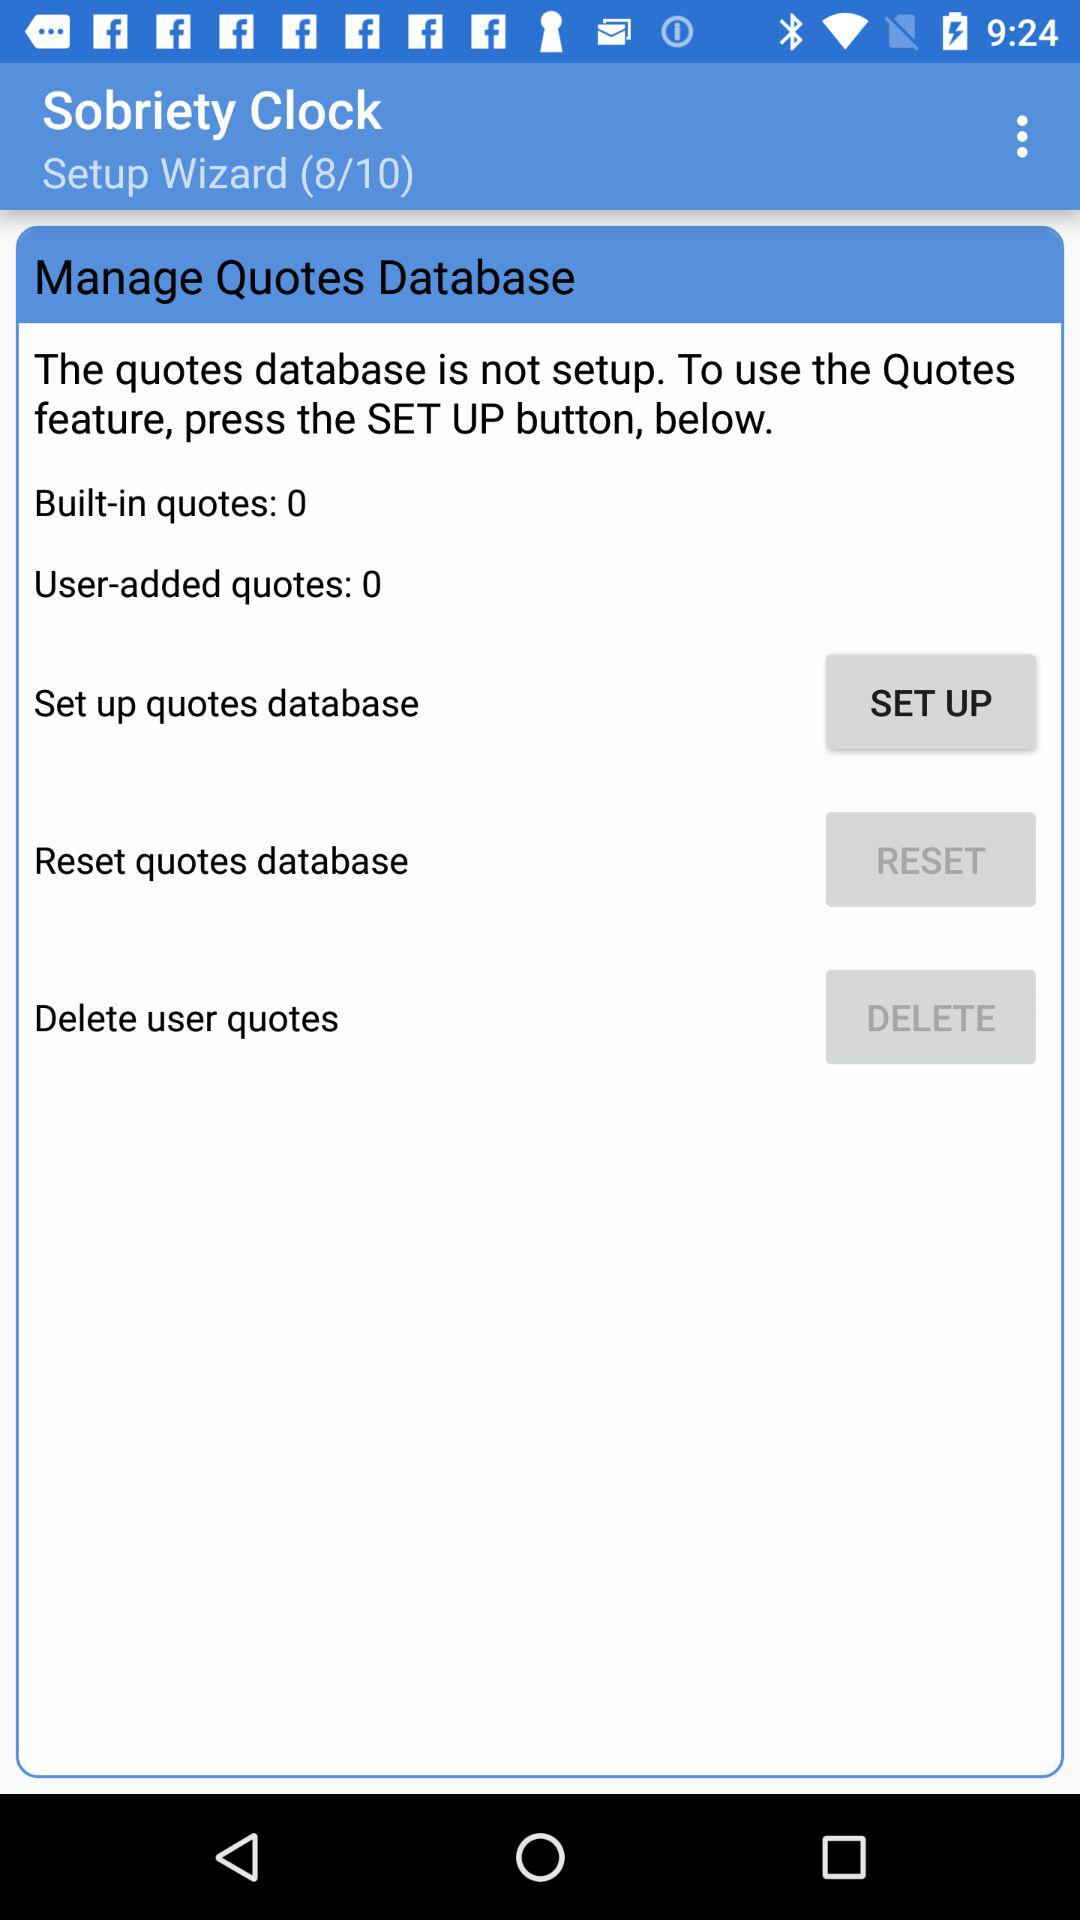How many user-added quotes are there?
Answer the question using a single word or phrase. 0 